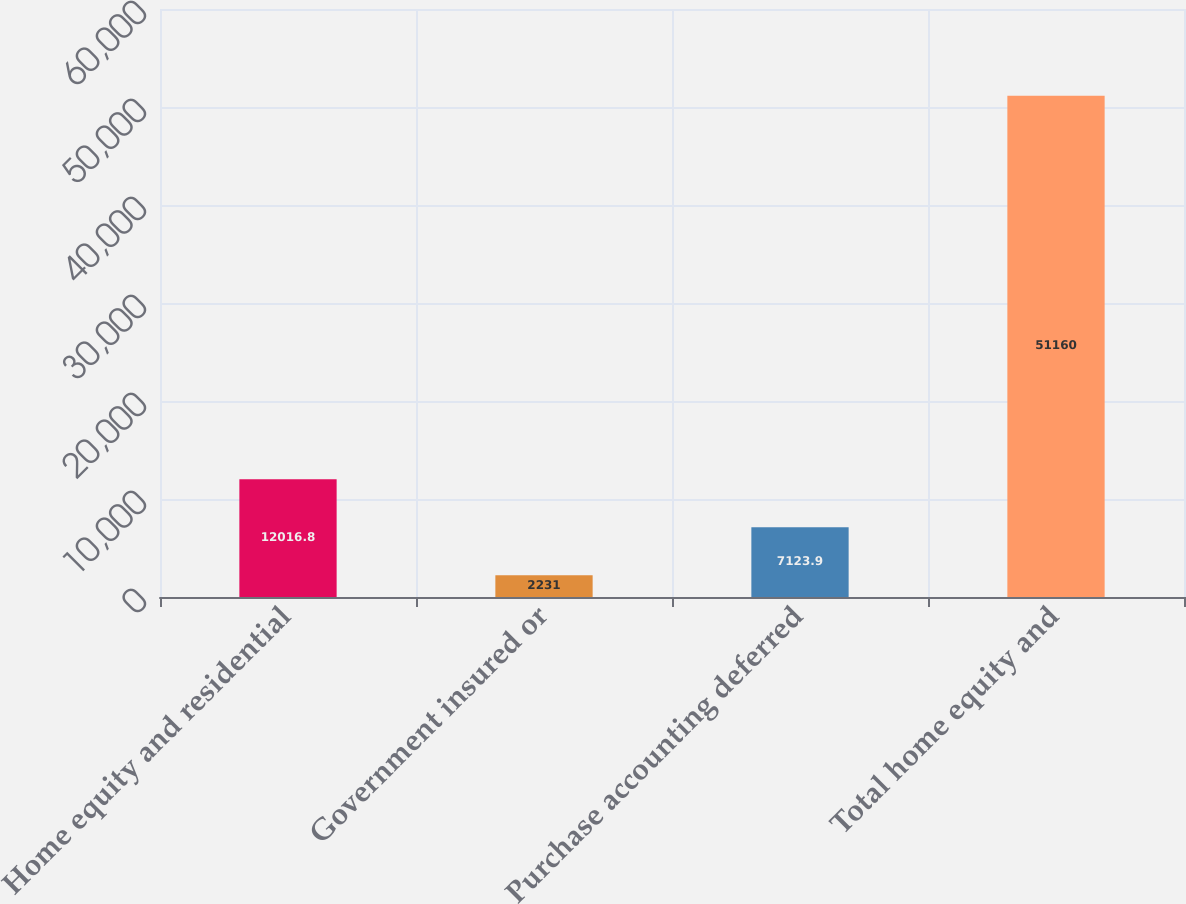<chart> <loc_0><loc_0><loc_500><loc_500><bar_chart><fcel>Home equity and residential<fcel>Government insured or<fcel>Purchase accounting deferred<fcel>Total home equity and<nl><fcel>12016.8<fcel>2231<fcel>7123.9<fcel>51160<nl></chart> 